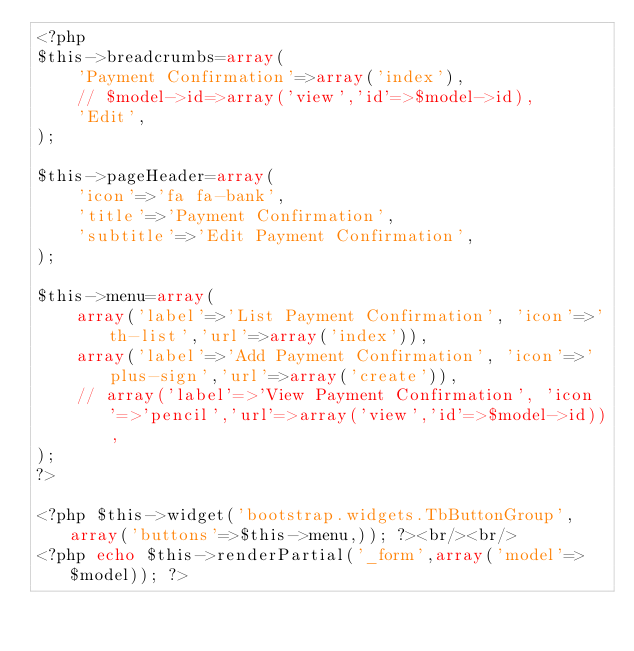<code> <loc_0><loc_0><loc_500><loc_500><_PHP_><?php
$this->breadcrumbs=array(
	'Payment Confirmation'=>array('index'),
	// $model->id=>array('view','id'=>$model->id),
	'Edit',
);

$this->pageHeader=array(
	'icon'=>'fa fa-bank',
	'title'=>'Payment Confirmation',
	'subtitle'=>'Edit Payment Confirmation',
);

$this->menu=array(
	array('label'=>'List Payment Confirmation', 'icon'=>'th-list','url'=>array('index')),
	array('label'=>'Add Payment Confirmation', 'icon'=>'plus-sign','url'=>array('create')),
	// array('label'=>'View Payment Confirmation', 'icon'=>'pencil','url'=>array('view','id'=>$model->id)),
);
?>

<?php $this->widget('bootstrap.widgets.TbButtonGroup',array('buttons'=>$this->menu,)); ?><br/><br/>
<?php echo $this->renderPartial('_form',array('model'=>$model)); ?></code> 